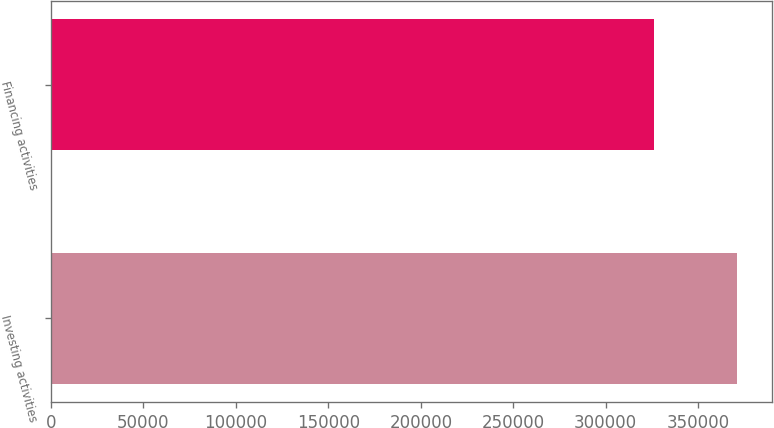Convert chart to OTSL. <chart><loc_0><loc_0><loc_500><loc_500><bar_chart><fcel>Investing activities<fcel>Financing activities<nl><fcel>371277<fcel>326022<nl></chart> 